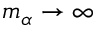Convert formula to latex. <formula><loc_0><loc_0><loc_500><loc_500>m _ { \alpha } \rightarrow \infty</formula> 